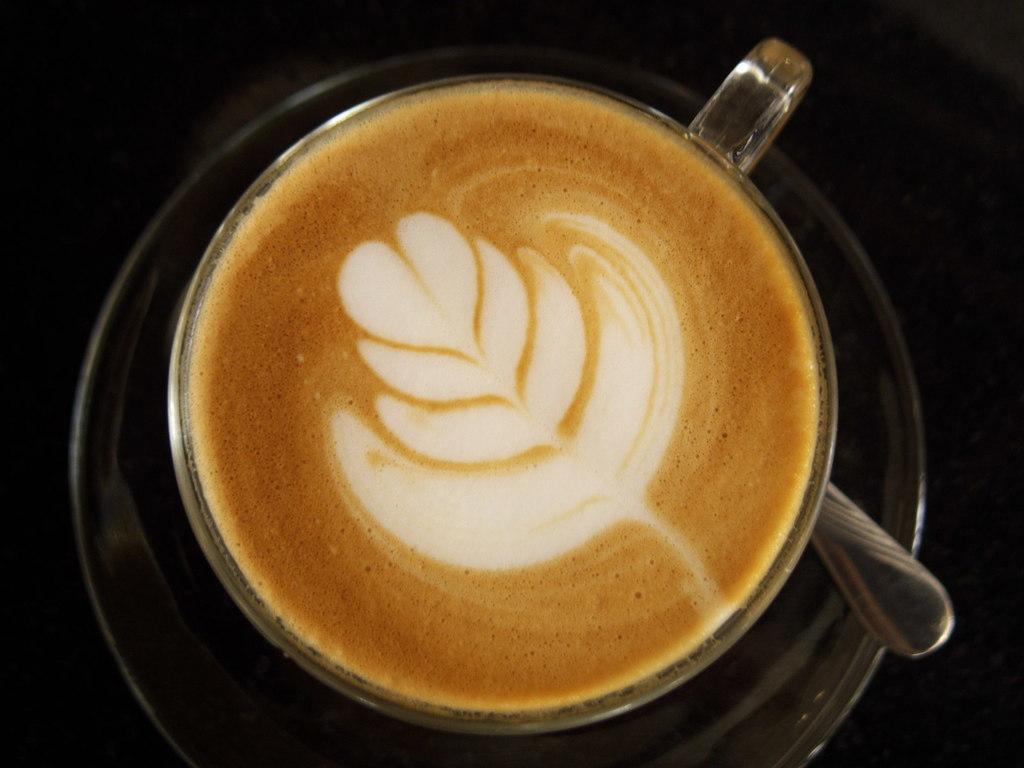Please provide a concise description of this image. In this picture there is a coffee in the cup. There is a cup and there is a spoon on the saucer. At the bottom there is a black background. 